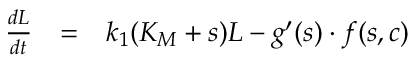<formula> <loc_0><loc_0><loc_500><loc_500>\begin{array} { r c l } { \frac { d L } { d t } } & { = } & { k _ { 1 } ( K _ { M } + s ) L - g ^ { \prime } ( s ) \cdot f ( s , c ) } \end{array}</formula> 